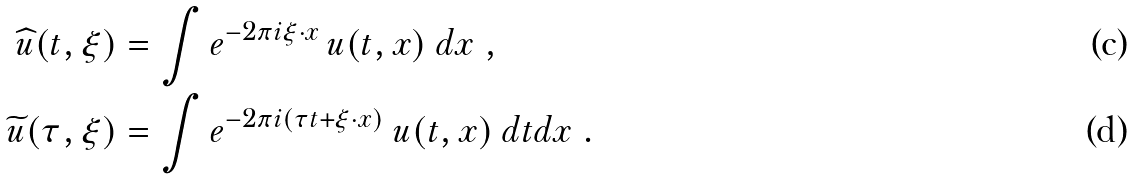<formula> <loc_0><loc_0><loc_500><loc_500>\widehat { u } ( t , \xi ) & = \int e ^ { - 2 \pi i \xi \cdot x } \, u ( t , x ) \ d x \ , \\ \widetilde { u } ( \tau , \xi ) & = \int e ^ { - 2 \pi i ( \tau t + \xi \cdot x ) } \ u ( t , x ) \ d t d x \ .</formula> 